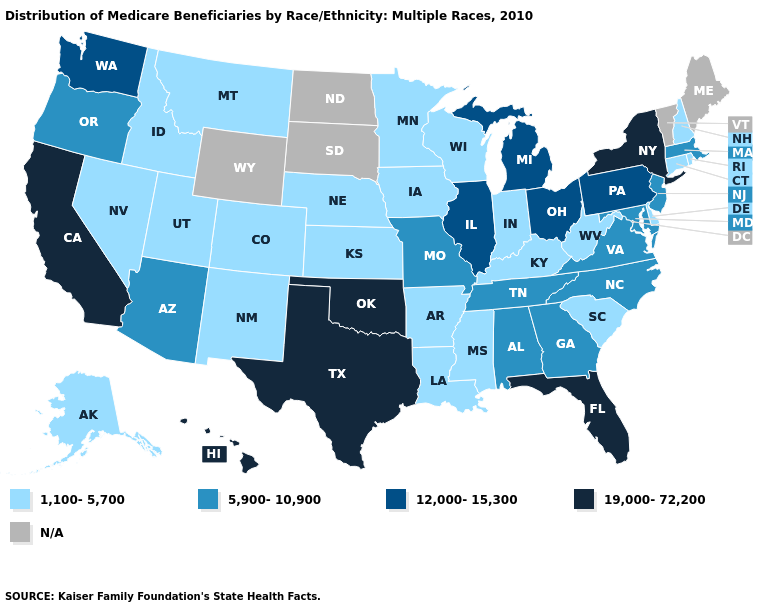Is the legend a continuous bar?
Be succinct. No. Among the states that border Indiana , does Kentucky have the highest value?
Keep it brief. No. Name the states that have a value in the range 1,100-5,700?
Quick response, please. Alaska, Arkansas, Colorado, Connecticut, Delaware, Idaho, Indiana, Iowa, Kansas, Kentucky, Louisiana, Minnesota, Mississippi, Montana, Nebraska, Nevada, New Hampshire, New Mexico, Rhode Island, South Carolina, Utah, West Virginia, Wisconsin. Which states hav the highest value in the Northeast?
Write a very short answer. New York. Does Hawaii have the highest value in the USA?
Write a very short answer. Yes. What is the value of Wyoming?
Be succinct. N/A. Name the states that have a value in the range 19,000-72,200?
Give a very brief answer. California, Florida, Hawaii, New York, Oklahoma, Texas. Among the states that border Texas , which have the highest value?
Keep it brief. Oklahoma. Name the states that have a value in the range 19,000-72,200?
Concise answer only. California, Florida, Hawaii, New York, Oklahoma, Texas. Does the first symbol in the legend represent the smallest category?
Write a very short answer. Yes. Name the states that have a value in the range 1,100-5,700?
Answer briefly. Alaska, Arkansas, Colorado, Connecticut, Delaware, Idaho, Indiana, Iowa, Kansas, Kentucky, Louisiana, Minnesota, Mississippi, Montana, Nebraska, Nevada, New Hampshire, New Mexico, Rhode Island, South Carolina, Utah, West Virginia, Wisconsin. Which states hav the highest value in the MidWest?
Be succinct. Illinois, Michigan, Ohio. Name the states that have a value in the range 5,900-10,900?
Quick response, please. Alabama, Arizona, Georgia, Maryland, Massachusetts, Missouri, New Jersey, North Carolina, Oregon, Tennessee, Virginia. What is the lowest value in states that border Washington?
Answer briefly. 1,100-5,700. What is the value of Connecticut?
Keep it brief. 1,100-5,700. 